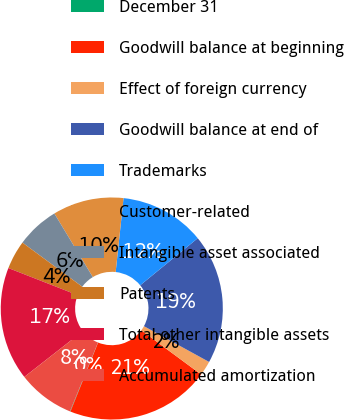Convert chart to OTSL. <chart><loc_0><loc_0><loc_500><loc_500><pie_chart><fcel>December 31<fcel>Goodwill balance at beginning<fcel>Effect of foreign currency<fcel>Goodwill balance at end of<fcel>Trademarks<fcel>Customer-related<fcel>Intangible asset associated<fcel>Patents<fcel>Total other intangible assets<fcel>Accumulated amortization<nl><fcel>0.07%<fcel>20.95%<fcel>2.13%<fcel>18.9%<fcel>12.4%<fcel>10.34%<fcel>6.23%<fcel>4.18%<fcel>16.5%<fcel>8.29%<nl></chart> 